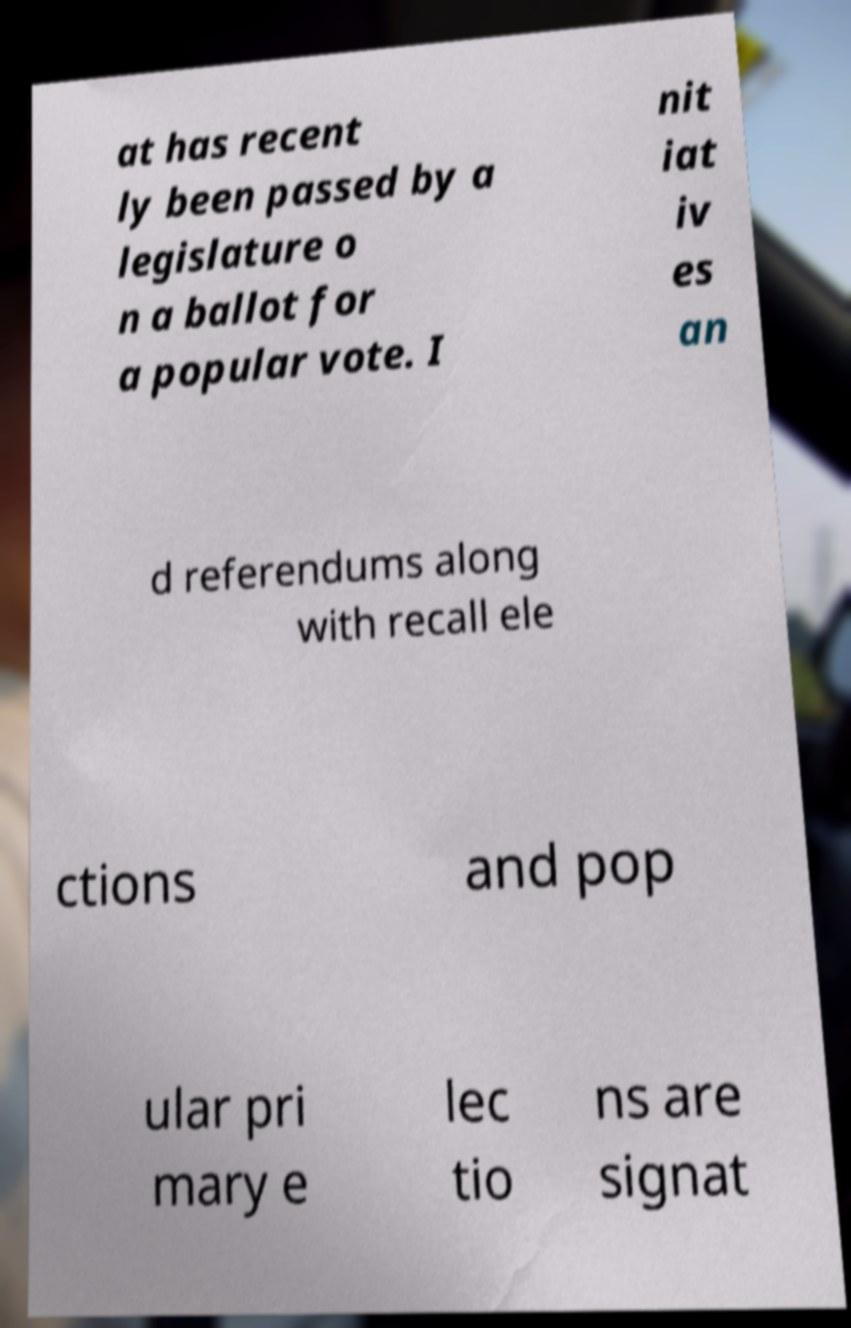Could you extract and type out the text from this image? at has recent ly been passed by a legislature o n a ballot for a popular vote. I nit iat iv es an d referendums along with recall ele ctions and pop ular pri mary e lec tio ns are signat 